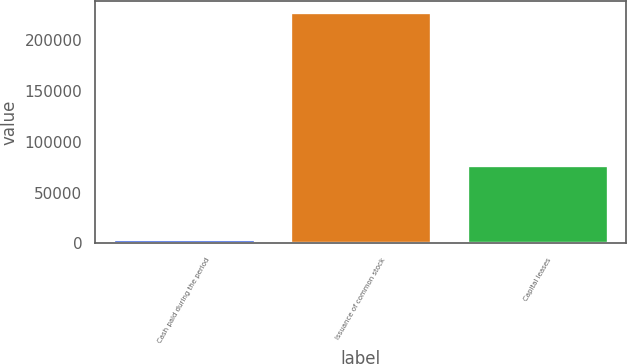Convert chart. <chart><loc_0><loc_0><loc_500><loc_500><bar_chart><fcel>Cash paid during the period<fcel>Issuance of common stock<fcel>Capital leases<nl><fcel>4335<fcel>227507<fcel>77427<nl></chart> 